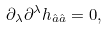<formula> <loc_0><loc_0><loc_500><loc_500>\partial _ { \lambda } \partial ^ { \lambda } h _ { \hat { a } \hat { a } } = 0 ,</formula> 